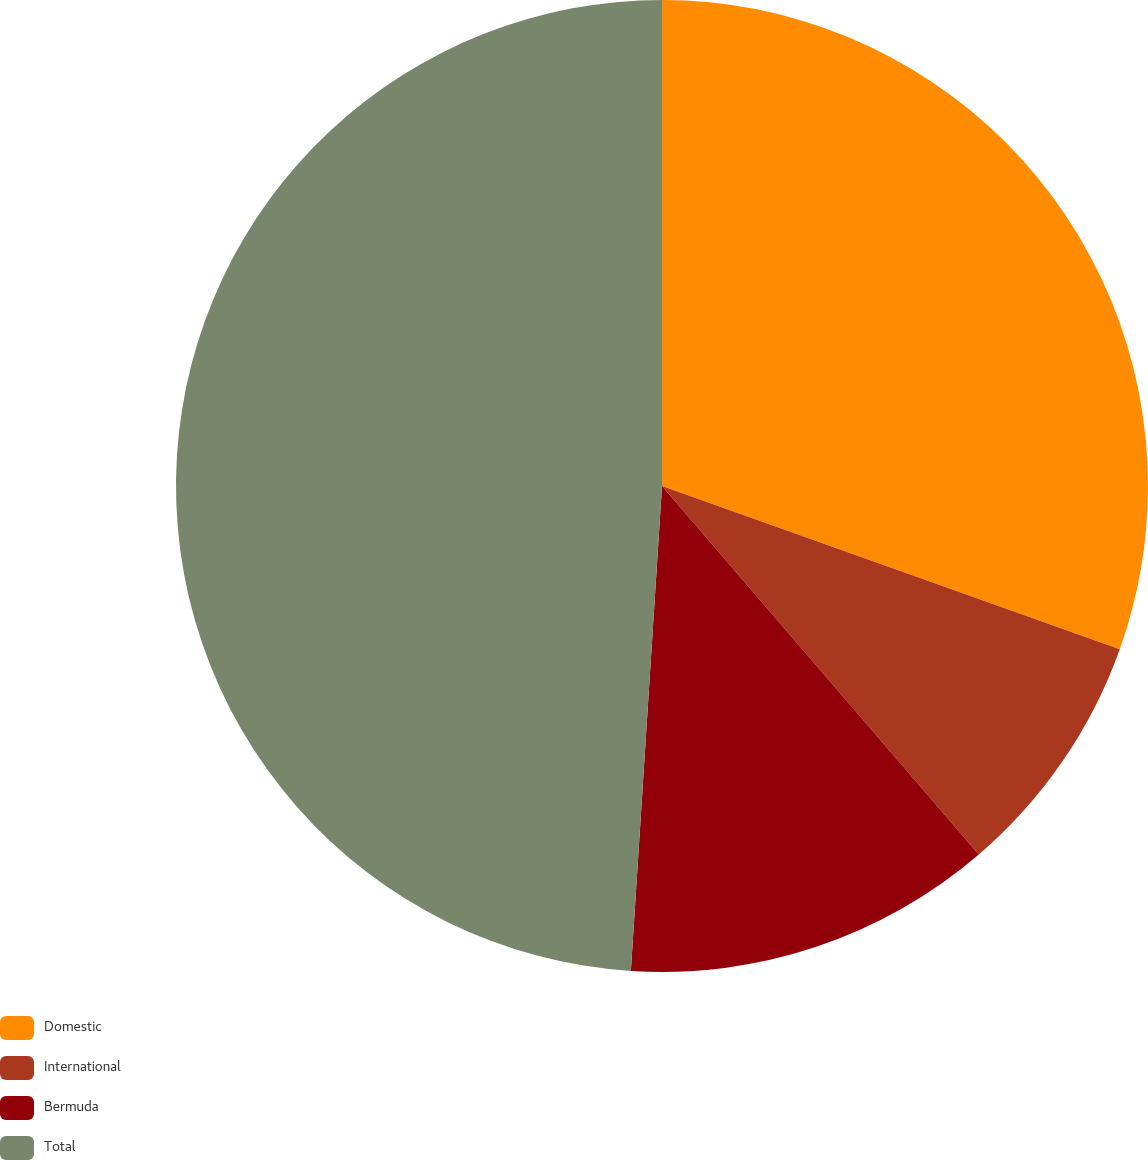Convert chart to OTSL. <chart><loc_0><loc_0><loc_500><loc_500><pie_chart><fcel>Domestic<fcel>International<fcel>Bermuda<fcel>Total<nl><fcel>30.45%<fcel>8.25%<fcel>12.32%<fcel>48.98%<nl></chart> 